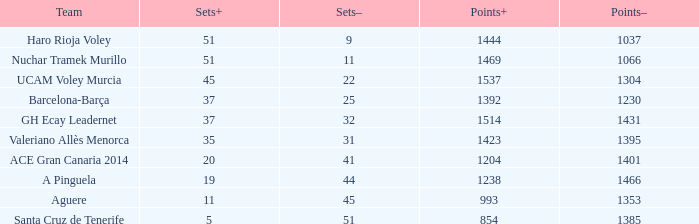Who is the team who had a Sets+ number smaller than 20, a Sets- number of 45, and a Points+ number smaller than 1238? Aguere. 